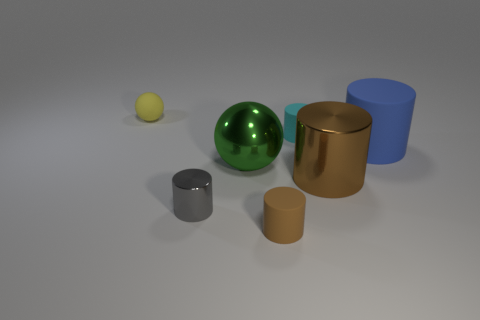How many things are matte cylinders left of the tiny cyan cylinder or tiny cyan shiny cylinders?
Your answer should be very brief. 1. What number of tiny matte things are both on the right side of the brown rubber cylinder and left of the large green ball?
Offer a terse response. 0. What number of things are either large metallic spheres that are behind the large brown shiny cylinder or spheres behind the blue object?
Provide a short and direct response. 2. What number of other things are the same shape as the large brown metallic object?
Your response must be concise. 4. Is the color of the metallic cylinder that is right of the brown rubber cylinder the same as the metallic ball?
Give a very brief answer. No. How many other things are there of the same size as the brown matte thing?
Provide a short and direct response. 3. Do the small cyan cylinder and the large brown cylinder have the same material?
Your answer should be compact. No. What color is the ball that is in front of the large blue matte cylinder that is on the right side of the big brown thing?
Ensure brevity in your answer.  Green. There is a cyan matte thing that is the same shape as the large blue thing; what size is it?
Make the answer very short. Small. Does the small metallic thing have the same color as the small sphere?
Offer a terse response. No. 